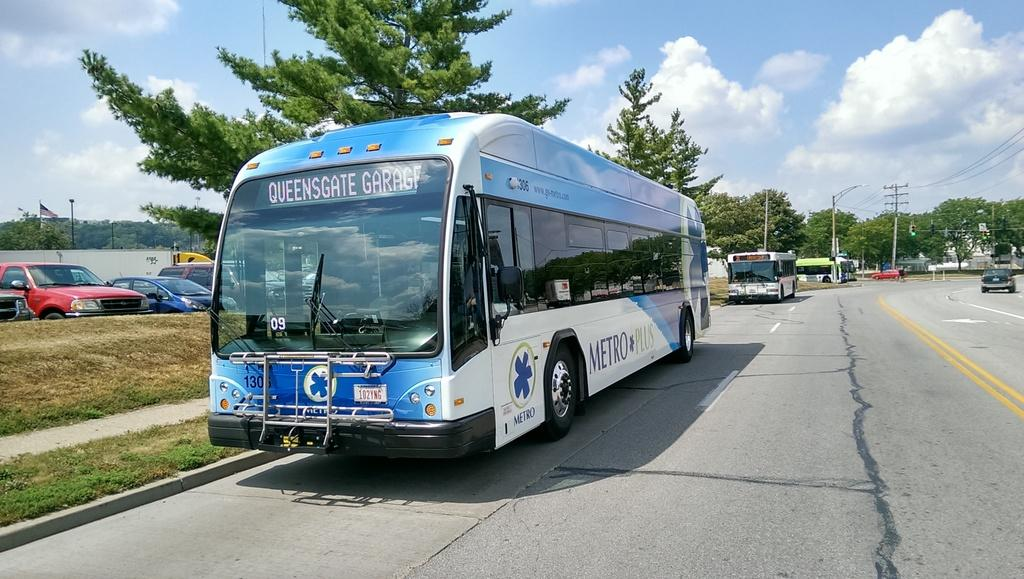<image>
Provide a brief description of the given image. A transit bus has Queensgate Garage displayed on the screen over the windshield. 